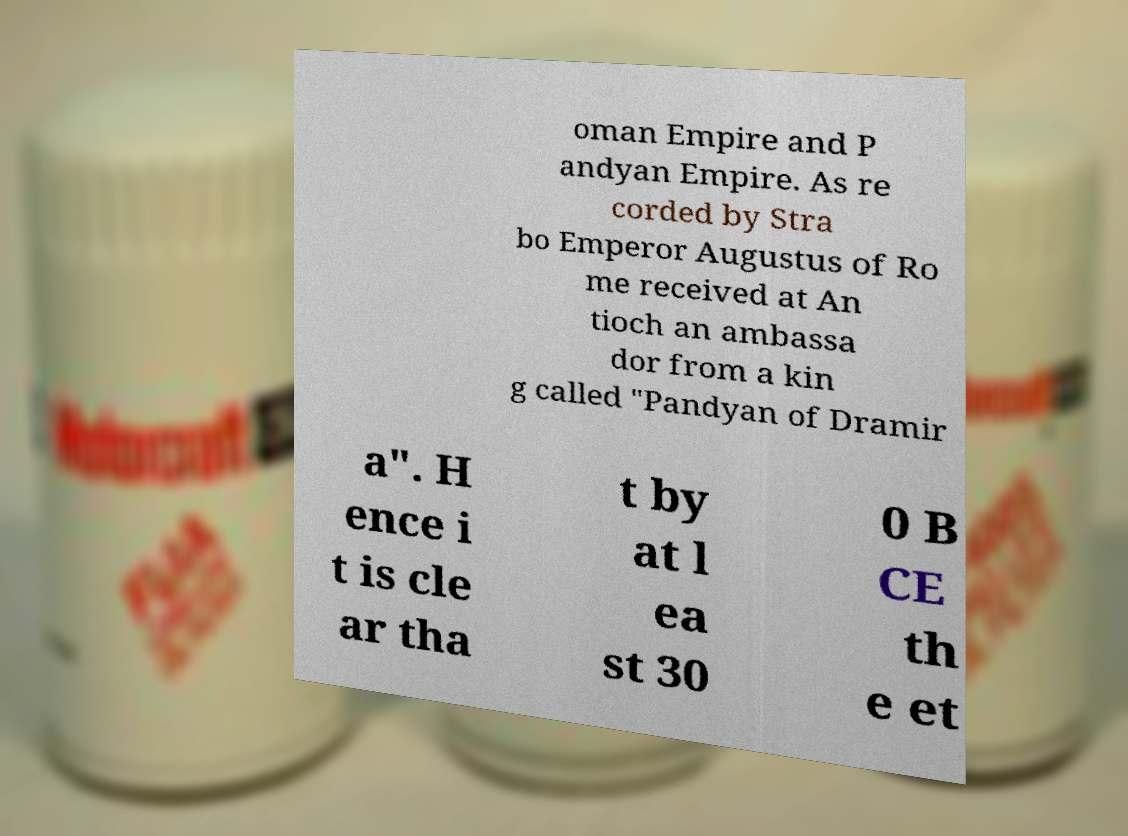There's text embedded in this image that I need extracted. Can you transcribe it verbatim? oman Empire and P andyan Empire. As re corded by Stra bo Emperor Augustus of Ro me received at An tioch an ambassa dor from a kin g called "Pandyan of Dramir a". H ence i t is cle ar tha t by at l ea st 30 0 B CE th e et 